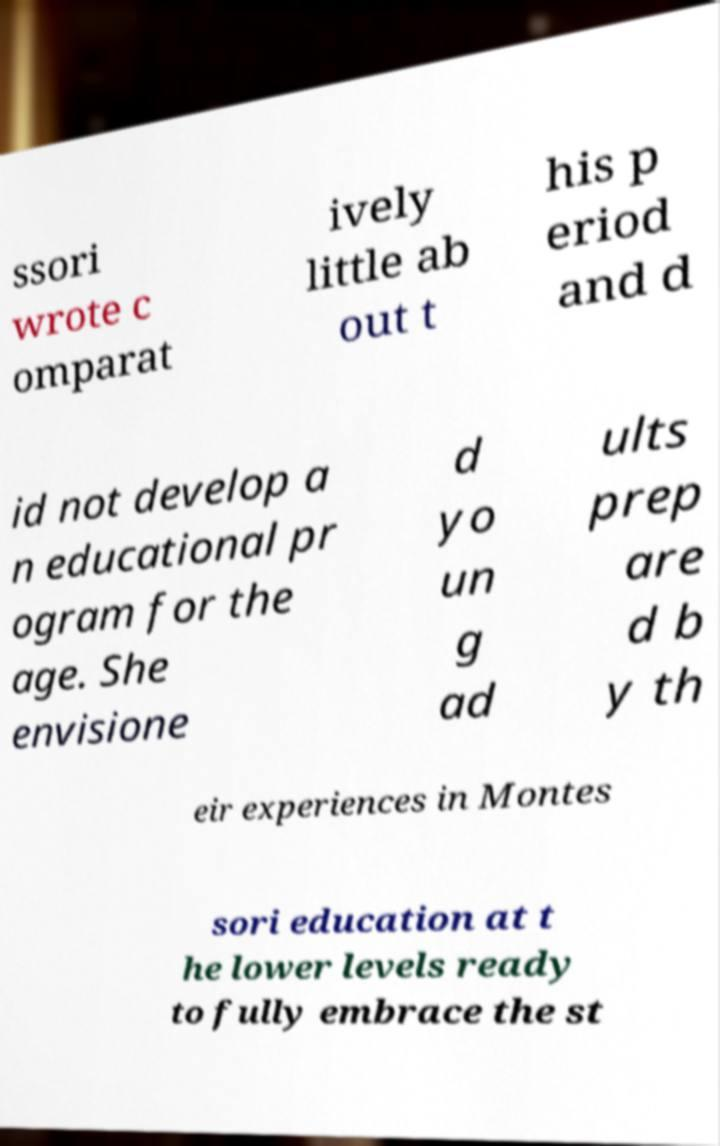Could you assist in decoding the text presented in this image and type it out clearly? ssori wrote c omparat ively little ab out t his p eriod and d id not develop a n educational pr ogram for the age. She envisione d yo un g ad ults prep are d b y th eir experiences in Montes sori education at t he lower levels ready to fully embrace the st 